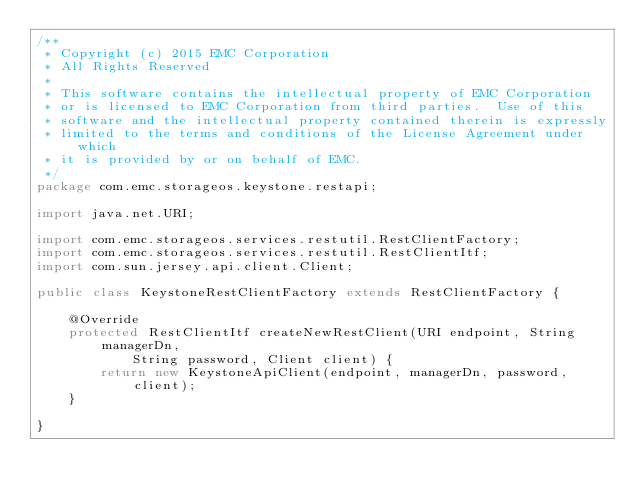<code> <loc_0><loc_0><loc_500><loc_500><_Java_>/**
 * Copyright (c) 2015 EMC Corporation
 * All Rights Reserved
 *
 * This software contains the intellectual property of EMC Corporation
 * or is licensed to EMC Corporation from third parties.  Use of this
 * software and the intellectual property contained therein is expressly
 * limited to the terms and conditions of the License Agreement under which
 * it is provided by or on behalf of EMC.
 */
package com.emc.storageos.keystone.restapi;

import java.net.URI;

import com.emc.storageos.services.restutil.RestClientFactory;
import com.emc.storageos.services.restutil.RestClientItf;
import com.sun.jersey.api.client.Client;

public class KeystoneRestClientFactory extends RestClientFactory {

    @Override
    protected RestClientItf createNewRestClient(URI endpoint, String managerDn,
            String password, Client client) {
        return new KeystoneApiClient(endpoint, managerDn, password, client);
    }

}
</code> 